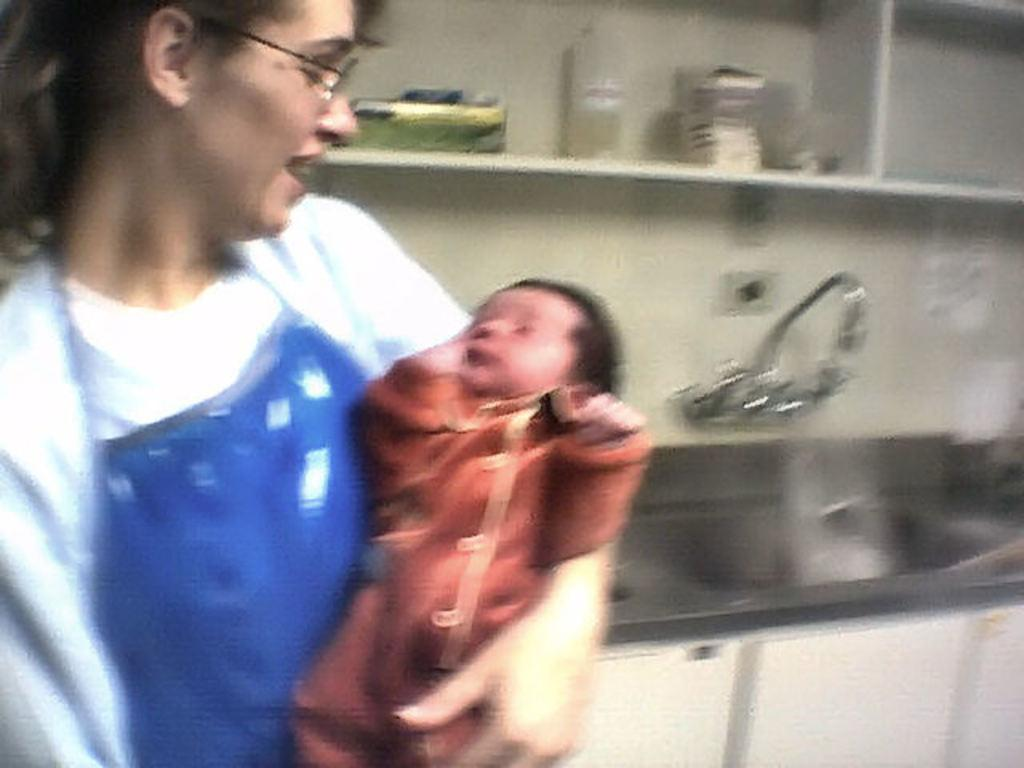What is the person in the image doing? The person is carrying a baby in the image. What can be seen on the wall in the image? There is a tap attached to the wall in the image. What is located near the tap? There is a sink in the image. What is on the shelf in the image? There are objects on a shelf in the image. What type of hat is the baby wearing in the image? There is no hat visible on the baby in the image. Can you tell me how many spots are on the tap in the image? There are no spots on the tap in the image; it is a smooth surface. 